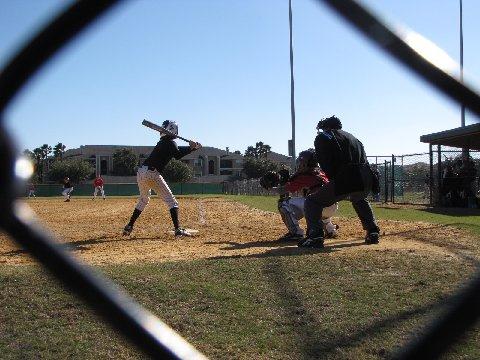Is this a major league game?
Write a very short answer. No. What Sport are these athletes playing?
Give a very brief answer. Baseball. Are we behind a fence?
Be succinct. Yes. Is there clouds in the sky?
Give a very brief answer. No. 